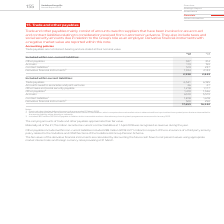From Vodafone Group Plc's financial document, Which financial years' information is shown in the table? The document shows two values: 2018 and 2019. From the document: "2019 2018 €m €m Included within non-current liabilities: Other payables 327 314 Accruals 113 159 Contrac 2019 2018 €m €m Included within non-current l..." Also, How much is the 2019 other payables included within non-current liabilities? According to the financial document, 327 (in millions). The relevant text states: "ed within non-current liabilities: Other payables 327 314 Accruals 113 159 Contract liabilities 1 574 237 Derivative financial instruments 2 1,924 2,133..." Also, How much is the 2018 other payables included within non-current liabilities? According to the financial document, 314 (in millions). The relevant text states: "ithin non-current liabilities: Other payables 327 314 Accruals 113 159 Contract liabilities 1 574 237 Derivative financial instruments 2 1,924 2,133 2,93..." Additionally, Between 2018 and 2019, which year had higher total trade and other payables included within current liabilities? According to the financial document, 2019. The relevant text states: "2019 2018 €m €m Included within non-current liabilities: Other payables 327 314 Accruals 113 159 Contrac..." Additionally, Between 2018 and 2019, which year had higher accruals included within non-current liabilities? According to the financial document, 2018. The relevant text states: "2019 2018 €m €m Included within non-current liabilities: Other payables 327 314 Accruals 113 159 Contract lia..." Also, can you calculate: How much is the 2019 other payables included within current liabilities excluding the amount payable in relation to the share buyback? Based on the calculation: 1,410-823, the result is 587 (in millions). This is based on the information: "ial security payable 1,218 1,177 Other payables 3 1,410 1,346 Accruals 6,120 5,579 Contract liabilities 1 1,818 1,678 Derivative financial instruments 2 52 ility, either directly or indirectly. 3 Incl..." The key data points involved are: 1,410, 823. 